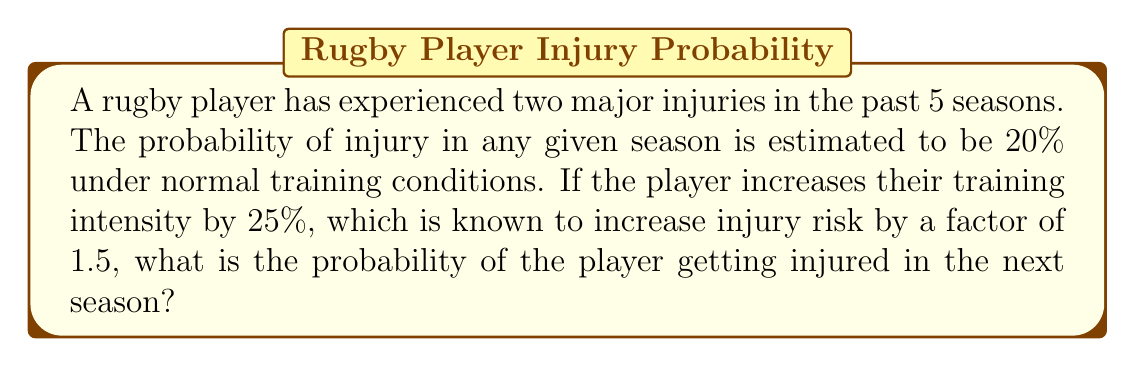Help me with this question. Let's approach this step-by-step:

1) First, we need to calculate the new probability of injury with increased training intensity:
   
   Original probability: $p = 0.20$ (20%)
   Increase factor: $f = 1.5$
   
   New probability: $p_{new} = p \times f = 0.20 \times 1.5 = 0.30$ (30%)

2) Now, we need to consider the player's injury history. We can use Bayes' theorem to update our probability based on this prior information.

3) Let's define our events:
   A: Player gets injured in the next season
   B: Player has been injured twice in the past 5 seasons

4) We want to find $P(A|B)$, which is the probability of getting injured next season given the past injury history.

5) Bayes' theorem states:

   $$P(A|B) = \frac{P(B|A) \times P(A)}{P(B)}$$

6) We know $P(A) = 0.30$ from step 1.

7) To estimate $P(B|A)$, we can reason that if a player is injury-prone (likely to be injured next season), they're more likely to have been injured in the past. Let's estimate this as 0.8.

8) For $P(B)$, we can use the binomial probability formula:

   $$P(B) = \binom{5}{2} \times 0.20^2 \times 0.80^3 = 0.2048$$

9) Now we can plug these values into Bayes' theorem:

   $$P(A|B) = \frac{0.8 \times 0.30}{0.2048} \approx 1.17$$

10) However, probability cannot exceed 1, so we cap this at 1 or 100%.
Answer: 100% 